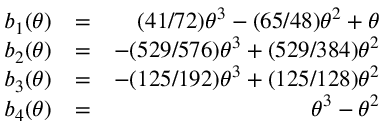<formula> <loc_0><loc_0><loc_500><loc_500>\begin{array} { r l r } { b _ { 1 } ( \theta ) } & { = } & { ( 4 1 / 7 2 ) \theta ^ { 3 } - ( 6 5 / 4 8 ) \theta ^ { 2 } + \theta } \\ { b _ { 2 } ( \theta ) } & { = } & { - ( 5 2 9 / 5 7 6 ) \theta ^ { 3 } + ( 5 2 9 / 3 8 4 ) \theta ^ { 2 } } \\ { b _ { 3 } ( \theta ) } & { = } & { - ( 1 2 5 / 1 9 2 ) \theta ^ { 3 } + ( 1 2 5 / 1 2 8 ) \theta ^ { 2 } } \\ { b _ { 4 } ( \theta ) } & { = } & { \theta ^ { 3 } - \theta ^ { 2 } } \end{array}</formula> 